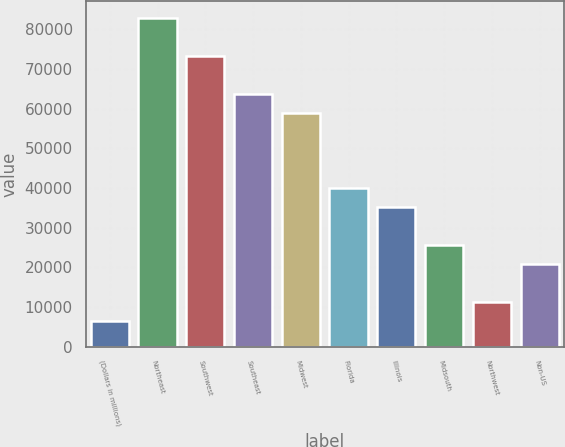Convert chart. <chart><loc_0><loc_0><loc_500><loc_500><bar_chart><fcel>(Dollars in millions)<fcel>Northeast<fcel>Southwest<fcel>Southeast<fcel>Midwest<fcel>Florida<fcel>Illinois<fcel>Midsouth<fcel>Northwest<fcel>Non-US<nl><fcel>6478.2<fcel>82913.4<fcel>73359<fcel>63804.6<fcel>59027.4<fcel>39918.6<fcel>35141.4<fcel>25587<fcel>11255.4<fcel>20809.8<nl></chart> 